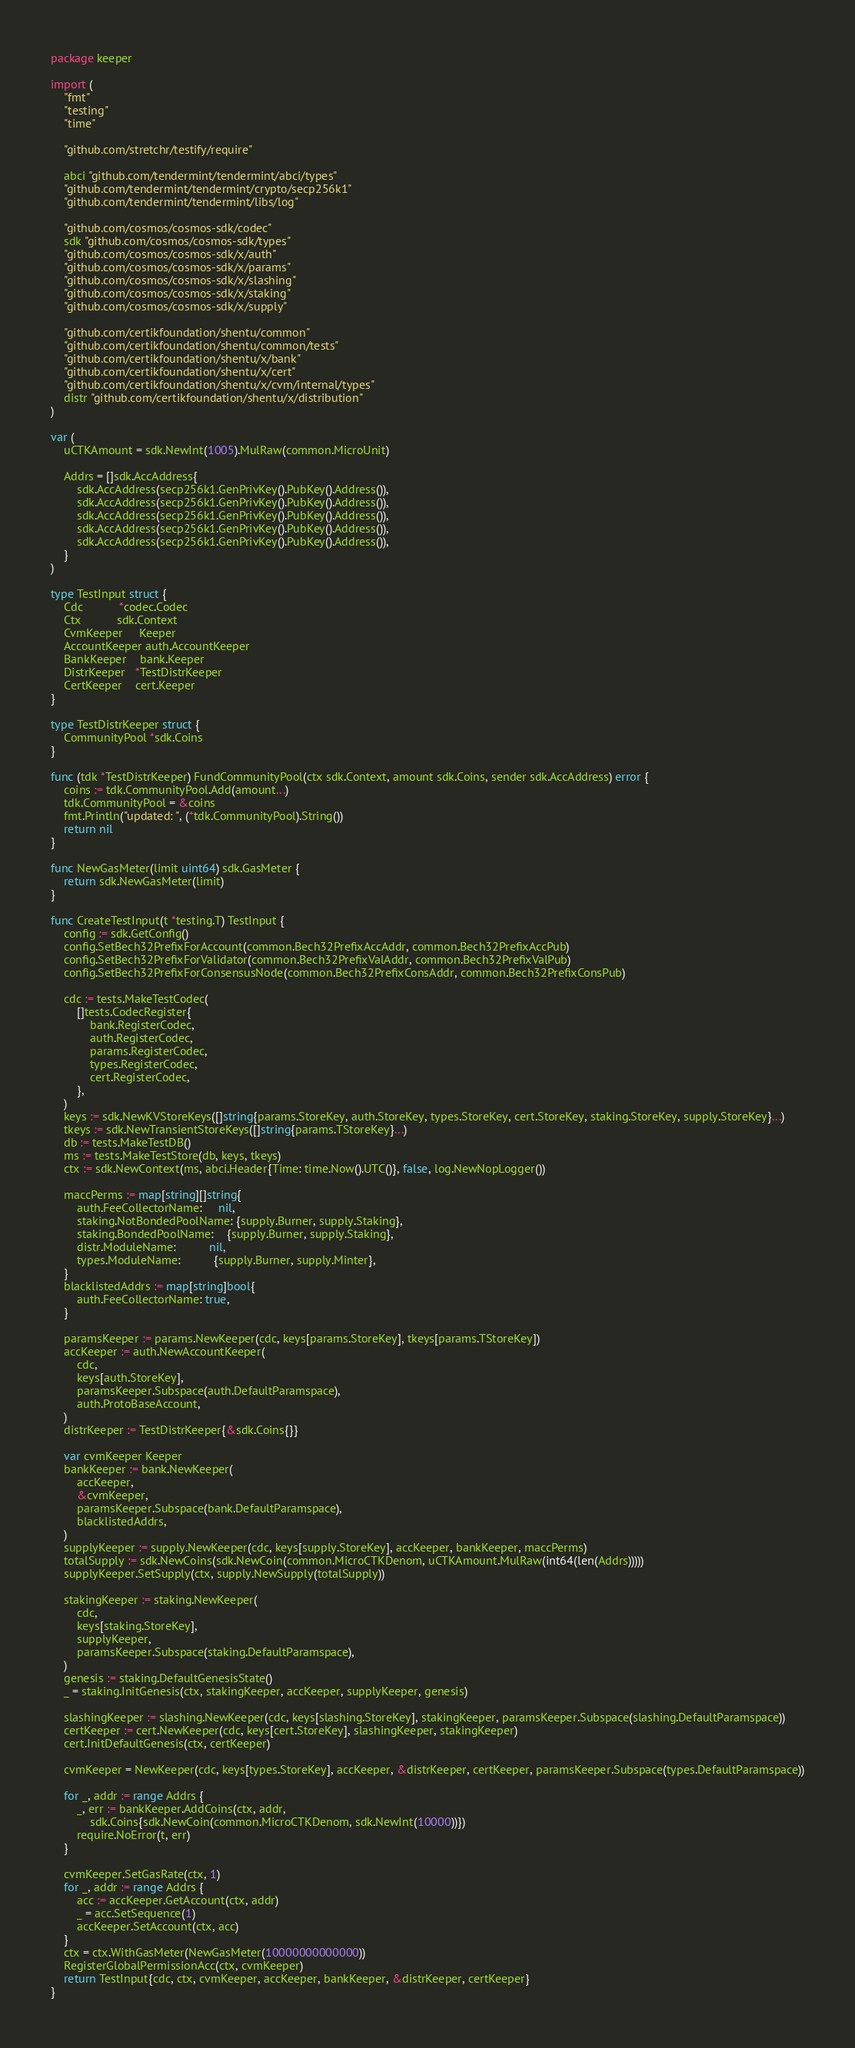Convert code to text. <code><loc_0><loc_0><loc_500><loc_500><_Go_>package keeper

import (
	"fmt"
	"testing"
	"time"

	"github.com/stretchr/testify/require"

	abci "github.com/tendermint/tendermint/abci/types"
	"github.com/tendermint/tendermint/crypto/secp256k1"
	"github.com/tendermint/tendermint/libs/log"

	"github.com/cosmos/cosmos-sdk/codec"
	sdk "github.com/cosmos/cosmos-sdk/types"
	"github.com/cosmos/cosmos-sdk/x/auth"
	"github.com/cosmos/cosmos-sdk/x/params"
	"github.com/cosmos/cosmos-sdk/x/slashing"
	"github.com/cosmos/cosmos-sdk/x/staking"
	"github.com/cosmos/cosmos-sdk/x/supply"

	"github.com/certikfoundation/shentu/common"
	"github.com/certikfoundation/shentu/common/tests"
	"github.com/certikfoundation/shentu/x/bank"
	"github.com/certikfoundation/shentu/x/cert"
	"github.com/certikfoundation/shentu/x/cvm/internal/types"
	distr "github.com/certikfoundation/shentu/x/distribution"
)

var (
	uCTKAmount = sdk.NewInt(1005).MulRaw(common.MicroUnit)

	Addrs = []sdk.AccAddress{
		sdk.AccAddress(secp256k1.GenPrivKey().PubKey().Address()),
		sdk.AccAddress(secp256k1.GenPrivKey().PubKey().Address()),
		sdk.AccAddress(secp256k1.GenPrivKey().PubKey().Address()),
		sdk.AccAddress(secp256k1.GenPrivKey().PubKey().Address()),
		sdk.AccAddress(secp256k1.GenPrivKey().PubKey().Address()),
	}
)

type TestInput struct {
	Cdc           *codec.Codec
	Ctx           sdk.Context
	CvmKeeper     Keeper
	AccountKeeper auth.AccountKeeper
	BankKeeper    bank.Keeper
	DistrKeeper   *TestDistrKeeper
	CertKeeper    cert.Keeper
}

type TestDistrKeeper struct {
	CommunityPool *sdk.Coins
}

func (tdk *TestDistrKeeper) FundCommunityPool(ctx sdk.Context, amount sdk.Coins, sender sdk.AccAddress) error {
	coins := tdk.CommunityPool.Add(amount...)
	tdk.CommunityPool = &coins
	fmt.Println("updated: ", (*tdk.CommunityPool).String())
	return nil
}

func NewGasMeter(limit uint64) sdk.GasMeter {
	return sdk.NewGasMeter(limit)
}

func CreateTestInput(t *testing.T) TestInput {
	config := sdk.GetConfig()
	config.SetBech32PrefixForAccount(common.Bech32PrefixAccAddr, common.Bech32PrefixAccPub)
	config.SetBech32PrefixForValidator(common.Bech32PrefixValAddr, common.Bech32PrefixValPub)
	config.SetBech32PrefixForConsensusNode(common.Bech32PrefixConsAddr, common.Bech32PrefixConsPub)

	cdc := tests.MakeTestCodec(
		[]tests.CodecRegister{
			bank.RegisterCodec,
			auth.RegisterCodec,
			params.RegisterCodec,
			types.RegisterCodec,
			cert.RegisterCodec,
		},
	)
	keys := sdk.NewKVStoreKeys([]string{params.StoreKey, auth.StoreKey, types.StoreKey, cert.StoreKey, staking.StoreKey, supply.StoreKey}...)
	tkeys := sdk.NewTransientStoreKeys([]string{params.TStoreKey}...)
	db := tests.MakeTestDB()
	ms := tests.MakeTestStore(db, keys, tkeys)
	ctx := sdk.NewContext(ms, abci.Header{Time: time.Now().UTC()}, false, log.NewNopLogger())

	maccPerms := map[string][]string{
		auth.FeeCollectorName:     nil,
		staking.NotBondedPoolName: {supply.Burner, supply.Staking},
		staking.BondedPoolName:    {supply.Burner, supply.Staking},
		distr.ModuleName:          nil,
		types.ModuleName:          {supply.Burner, supply.Minter},
	}
	blacklistedAddrs := map[string]bool{
		auth.FeeCollectorName: true,
	}

	paramsKeeper := params.NewKeeper(cdc, keys[params.StoreKey], tkeys[params.TStoreKey])
	accKeeper := auth.NewAccountKeeper(
		cdc,
		keys[auth.StoreKey],
		paramsKeeper.Subspace(auth.DefaultParamspace),
		auth.ProtoBaseAccount,
	)
	distrKeeper := TestDistrKeeper{&sdk.Coins{}}

	var cvmKeeper Keeper
	bankKeeper := bank.NewKeeper(
		accKeeper,
		&cvmKeeper,
		paramsKeeper.Subspace(bank.DefaultParamspace),
		blacklistedAddrs,
	)
	supplyKeeper := supply.NewKeeper(cdc, keys[supply.StoreKey], accKeeper, bankKeeper, maccPerms)
	totalSupply := sdk.NewCoins(sdk.NewCoin(common.MicroCTKDenom, uCTKAmount.MulRaw(int64(len(Addrs)))))
	supplyKeeper.SetSupply(ctx, supply.NewSupply(totalSupply))

	stakingKeeper := staking.NewKeeper(
		cdc,
		keys[staking.StoreKey],
		supplyKeeper,
		paramsKeeper.Subspace(staking.DefaultParamspace),
	)
	genesis := staking.DefaultGenesisState()
	_ = staking.InitGenesis(ctx, stakingKeeper, accKeeper, supplyKeeper, genesis)

	slashingKeeper := slashing.NewKeeper(cdc, keys[slashing.StoreKey], stakingKeeper, paramsKeeper.Subspace(slashing.DefaultParamspace))
	certKeeper := cert.NewKeeper(cdc, keys[cert.StoreKey], slashingKeeper, stakingKeeper)
	cert.InitDefaultGenesis(ctx, certKeeper)

	cvmKeeper = NewKeeper(cdc, keys[types.StoreKey], accKeeper, &distrKeeper, certKeeper, paramsKeeper.Subspace(types.DefaultParamspace))

	for _, addr := range Addrs {
		_, err := bankKeeper.AddCoins(ctx, addr,
			sdk.Coins{sdk.NewCoin(common.MicroCTKDenom, sdk.NewInt(10000))})
		require.NoError(t, err)
	}

	cvmKeeper.SetGasRate(ctx, 1)
	for _, addr := range Addrs {
		acc := accKeeper.GetAccount(ctx, addr)
		_ = acc.SetSequence(1)
		accKeeper.SetAccount(ctx, acc)
	}
	ctx = ctx.WithGasMeter(NewGasMeter(10000000000000))
	RegisterGlobalPermissionAcc(ctx, cvmKeeper)
	return TestInput{cdc, ctx, cvmKeeper, accKeeper, bankKeeper, &distrKeeper, certKeeper}
}
</code> 